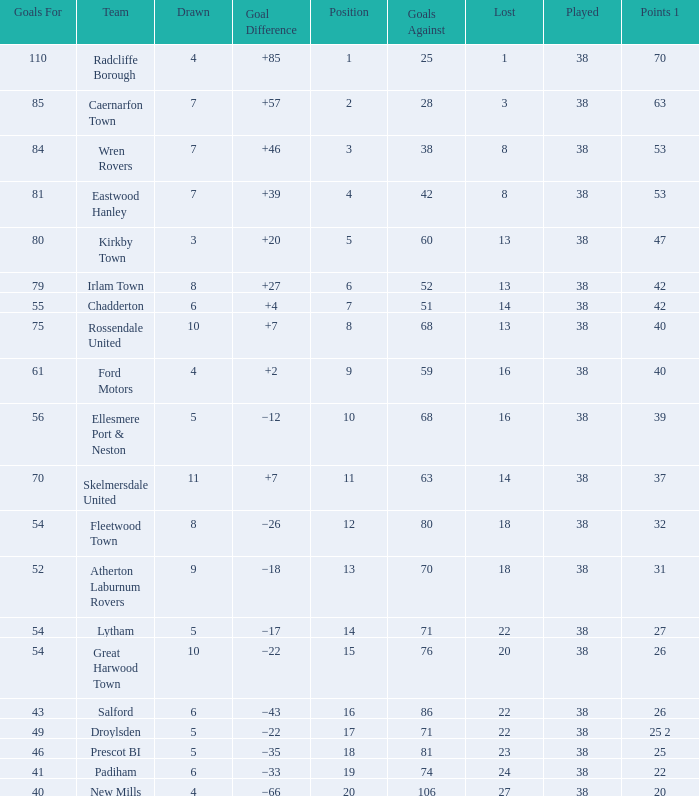Which Lost has a Position larger than 5, and Points 1 of 37, and less than 63 Goals Against? None. 